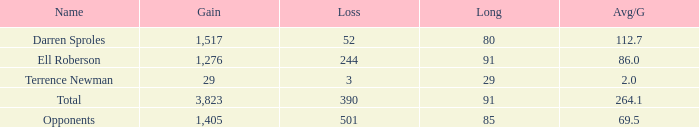What is the combined amount of all median yards gained when the yards gained is under 1,276 and lost more than 3 yards? None. 